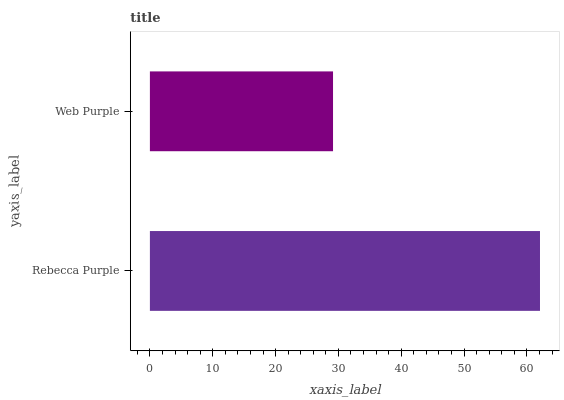Is Web Purple the minimum?
Answer yes or no. Yes. Is Rebecca Purple the maximum?
Answer yes or no. Yes. Is Web Purple the maximum?
Answer yes or no. No. Is Rebecca Purple greater than Web Purple?
Answer yes or no. Yes. Is Web Purple less than Rebecca Purple?
Answer yes or no. Yes. Is Web Purple greater than Rebecca Purple?
Answer yes or no. No. Is Rebecca Purple less than Web Purple?
Answer yes or no. No. Is Rebecca Purple the high median?
Answer yes or no. Yes. Is Web Purple the low median?
Answer yes or no. Yes. Is Web Purple the high median?
Answer yes or no. No. Is Rebecca Purple the low median?
Answer yes or no. No. 